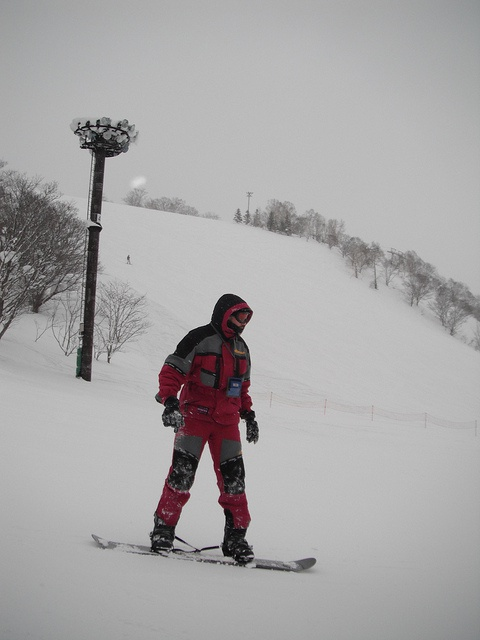Describe the objects in this image and their specific colors. I can see people in darkgray, black, maroon, and gray tones and snowboard in darkgray, gray, and black tones in this image. 